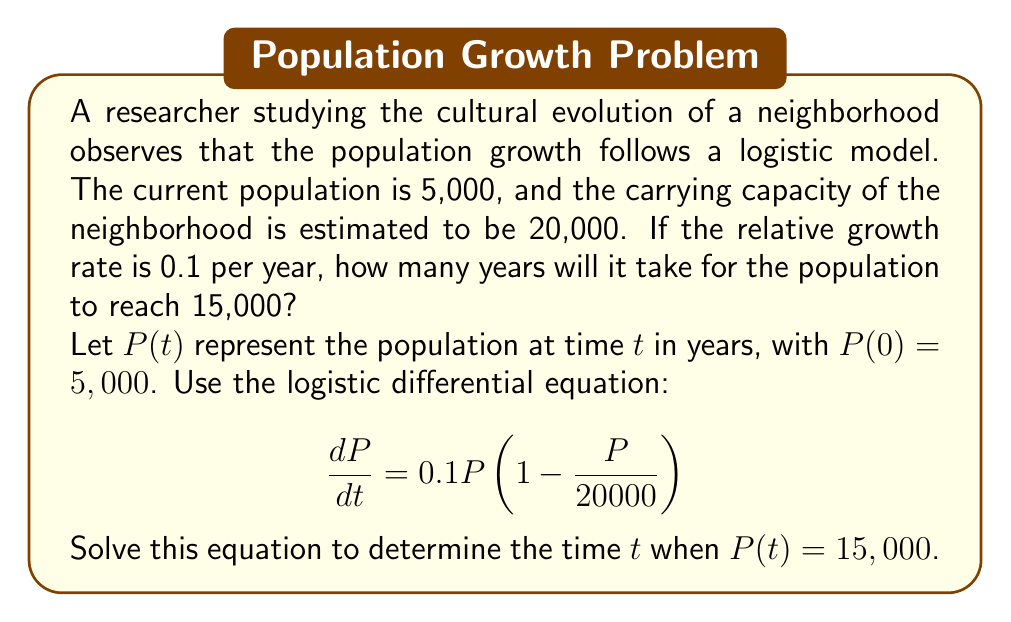Teach me how to tackle this problem. To solve this problem, we'll follow these steps:

1) The logistic differential equation is given by:
   $$\frac{dP}{dt} = rP(1 - \frac{P}{K})$$
   where $r$ is the relative growth rate and $K$ is the carrying capacity.

2) In this case, $r = 0.1$, $K = 20,000$, and $P(0) = 5,000$.

3) The solution to the logistic differential equation is:
   $$P(t) = \frac{K}{1 + (\frac{K}{P_0} - 1)e^{-rt}}$$

4) Substituting our values:
   $$P(t) = \frac{20000}{1 + (\frac{20000}{5000} - 1)e^{-0.1t}}$$

5) We want to find $t$ when $P(t) = 15,000$. So let's set up the equation:
   $$15000 = \frac{20000}{1 + (\frac{20000}{5000} - 1)e^{-0.1t}}$$

6) Solve for $t$:
   $$1 + (\frac{20000}{5000} - 1)e^{-0.1t} = \frac{20000}{15000}$$
   $$(\frac{20000}{5000} - 1)e^{-0.1t} = \frac{20000}{15000} - 1$$
   $$3e^{-0.1t} = \frac{1}{3}$$
   $$e^{-0.1t} = \frac{1}{9}$$
   $$-0.1t = \ln(\frac{1}{9})$$
   $$t = -\frac{\ln(\frac{1}{9})}{0.1} \approx 22.0$$

Therefore, it will take approximately 22 years for the population to reach 15,000.
Answer: 22 years 